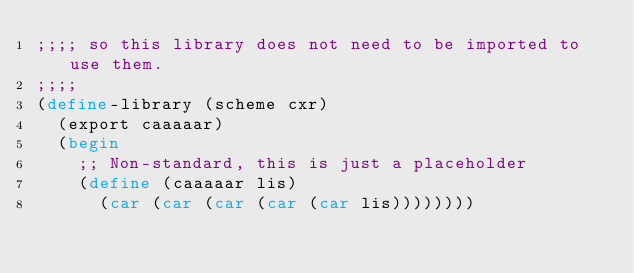Convert code to text. <code><loc_0><loc_0><loc_500><loc_500><_Scheme_>;;;; so this library does not need to be imported to use them.
;;;;
(define-library (scheme cxr)
  (export caaaaar)
  (begin 
    ;; Non-standard, this is just a placeholder
    (define (caaaaar lis)
      (car (car (car (car (car lis))))))))
</code> 